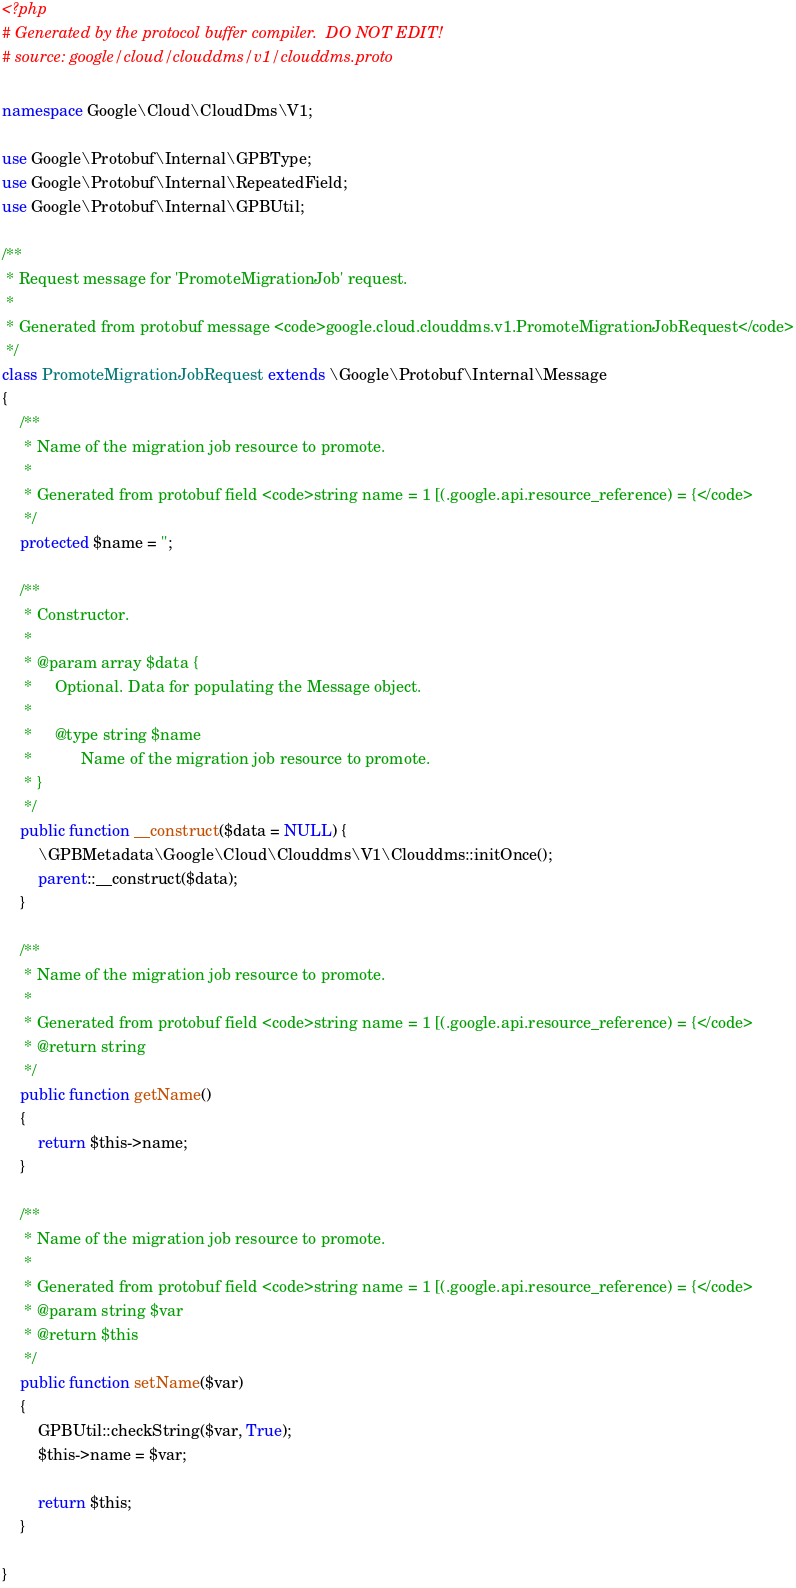Convert code to text. <code><loc_0><loc_0><loc_500><loc_500><_PHP_><?php
# Generated by the protocol buffer compiler.  DO NOT EDIT!
# source: google/cloud/clouddms/v1/clouddms.proto

namespace Google\Cloud\CloudDms\V1;

use Google\Protobuf\Internal\GPBType;
use Google\Protobuf\Internal\RepeatedField;
use Google\Protobuf\Internal\GPBUtil;

/**
 * Request message for 'PromoteMigrationJob' request.
 *
 * Generated from protobuf message <code>google.cloud.clouddms.v1.PromoteMigrationJobRequest</code>
 */
class PromoteMigrationJobRequest extends \Google\Protobuf\Internal\Message
{
    /**
     * Name of the migration job resource to promote.
     *
     * Generated from protobuf field <code>string name = 1 [(.google.api.resource_reference) = {</code>
     */
    protected $name = '';

    /**
     * Constructor.
     *
     * @param array $data {
     *     Optional. Data for populating the Message object.
     *
     *     @type string $name
     *           Name of the migration job resource to promote.
     * }
     */
    public function __construct($data = NULL) {
        \GPBMetadata\Google\Cloud\Clouddms\V1\Clouddms::initOnce();
        parent::__construct($data);
    }

    /**
     * Name of the migration job resource to promote.
     *
     * Generated from protobuf field <code>string name = 1 [(.google.api.resource_reference) = {</code>
     * @return string
     */
    public function getName()
    {
        return $this->name;
    }

    /**
     * Name of the migration job resource to promote.
     *
     * Generated from protobuf field <code>string name = 1 [(.google.api.resource_reference) = {</code>
     * @param string $var
     * @return $this
     */
    public function setName($var)
    {
        GPBUtil::checkString($var, True);
        $this->name = $var;

        return $this;
    }

}

</code> 